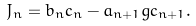Convert formula to latex. <formula><loc_0><loc_0><loc_500><loc_500>J _ { n } = b _ { n } c _ { n } - a _ { n + 1 } g c _ { n + 1 } .</formula> 